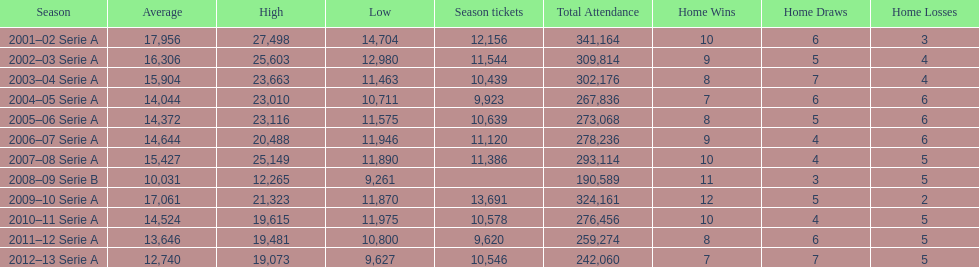What was the average attendance in 2008? 10,031. 